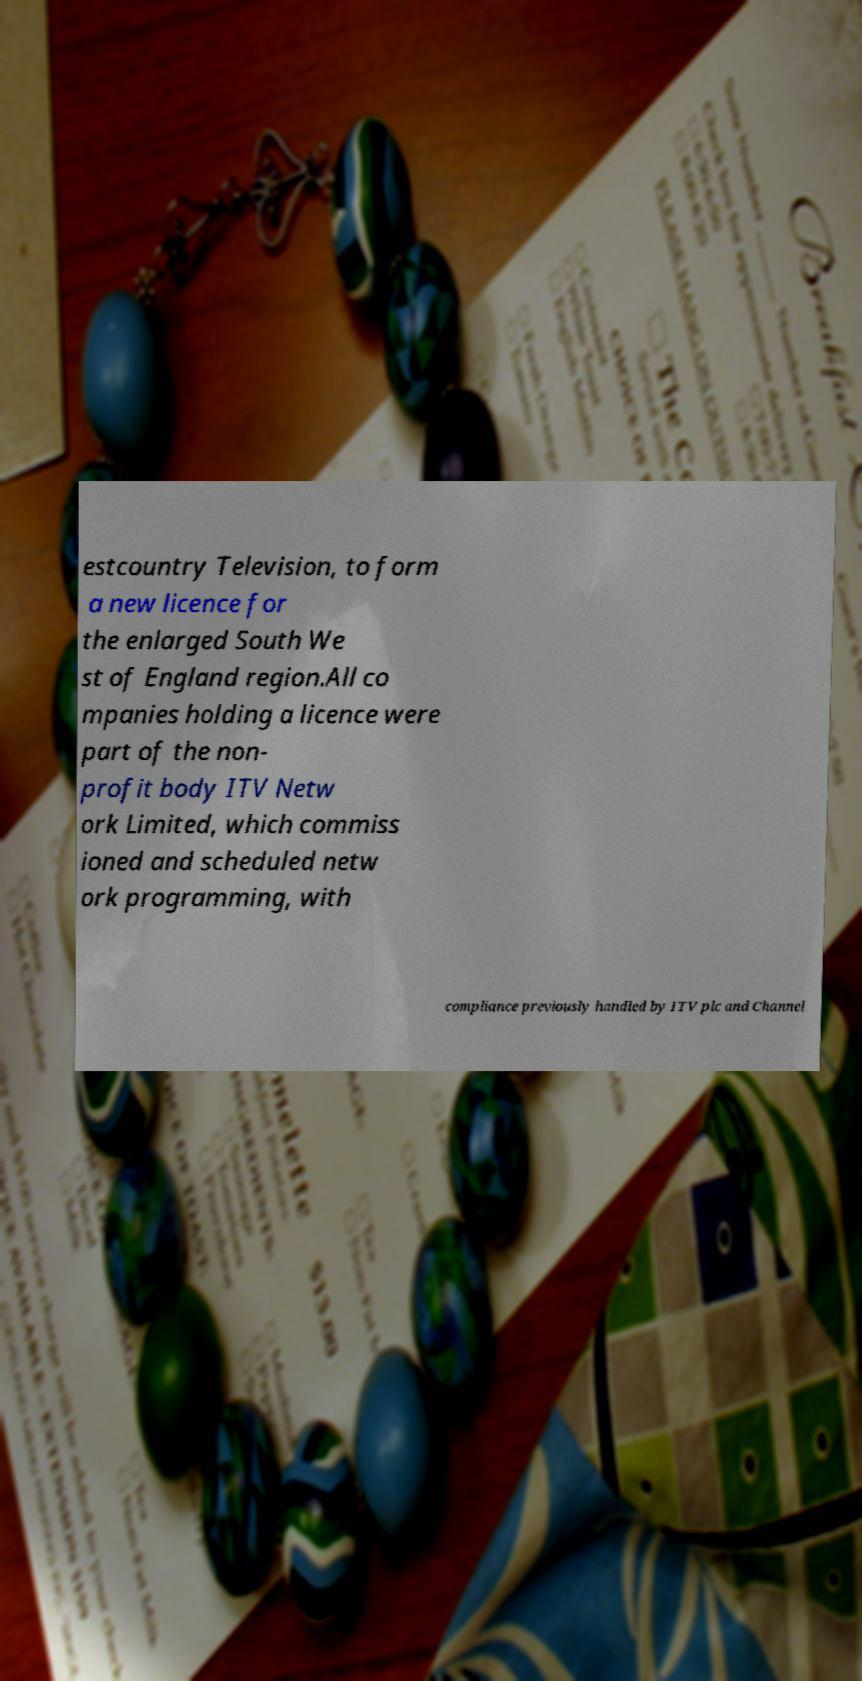Could you assist in decoding the text presented in this image and type it out clearly? estcountry Television, to form a new licence for the enlarged South We st of England region.All co mpanies holding a licence were part of the non- profit body ITV Netw ork Limited, which commiss ioned and scheduled netw ork programming, with compliance previously handled by ITV plc and Channel 